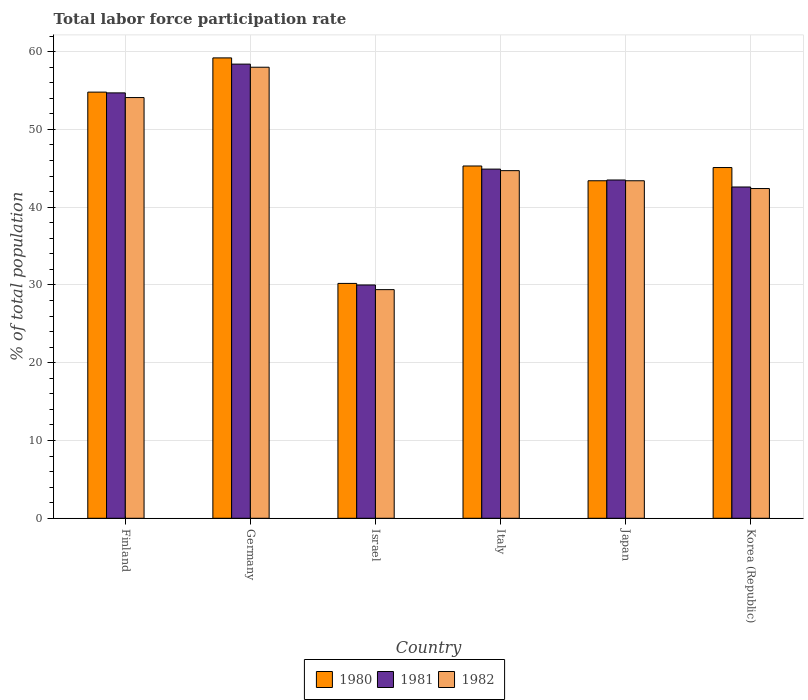How many different coloured bars are there?
Provide a short and direct response. 3. Are the number of bars per tick equal to the number of legend labels?
Give a very brief answer. Yes. Are the number of bars on each tick of the X-axis equal?
Ensure brevity in your answer.  Yes. How many bars are there on the 6th tick from the right?
Offer a very short reply. 3. In how many cases, is the number of bars for a given country not equal to the number of legend labels?
Provide a short and direct response. 0. What is the total labor force participation rate in 1982 in Israel?
Give a very brief answer. 29.4. Across all countries, what is the maximum total labor force participation rate in 1981?
Make the answer very short. 58.4. Across all countries, what is the minimum total labor force participation rate in 1982?
Provide a succinct answer. 29.4. What is the total total labor force participation rate in 1980 in the graph?
Your answer should be very brief. 278. What is the difference between the total labor force participation rate in 1981 in Germany and that in Italy?
Your answer should be compact. 13.5. What is the difference between the total labor force participation rate in 1981 in Germany and the total labor force participation rate in 1982 in Korea (Republic)?
Offer a very short reply. 16. What is the average total labor force participation rate in 1982 per country?
Make the answer very short. 45.33. What is the difference between the total labor force participation rate of/in 1982 and total labor force participation rate of/in 1981 in Italy?
Make the answer very short. -0.2. What is the ratio of the total labor force participation rate in 1980 in Finland to that in Italy?
Offer a terse response. 1.21. Is the difference between the total labor force participation rate in 1982 in Germany and Italy greater than the difference between the total labor force participation rate in 1981 in Germany and Italy?
Provide a succinct answer. No. What is the difference between the highest and the lowest total labor force participation rate in 1981?
Make the answer very short. 28.4. In how many countries, is the total labor force participation rate in 1981 greater than the average total labor force participation rate in 1981 taken over all countries?
Offer a very short reply. 2. What does the 3rd bar from the left in Finland represents?
Give a very brief answer. 1982. What does the 2nd bar from the right in Israel represents?
Your answer should be compact. 1981. Is it the case that in every country, the sum of the total labor force participation rate in 1980 and total labor force participation rate in 1982 is greater than the total labor force participation rate in 1981?
Offer a very short reply. Yes. How many countries are there in the graph?
Ensure brevity in your answer.  6. Are the values on the major ticks of Y-axis written in scientific E-notation?
Offer a terse response. No. Does the graph contain any zero values?
Your answer should be compact. No. Does the graph contain grids?
Offer a terse response. Yes. How many legend labels are there?
Offer a very short reply. 3. How are the legend labels stacked?
Your response must be concise. Horizontal. What is the title of the graph?
Keep it short and to the point. Total labor force participation rate. What is the label or title of the X-axis?
Keep it short and to the point. Country. What is the label or title of the Y-axis?
Ensure brevity in your answer.  % of total population. What is the % of total population of 1980 in Finland?
Keep it short and to the point. 54.8. What is the % of total population of 1981 in Finland?
Your answer should be compact. 54.7. What is the % of total population in 1982 in Finland?
Your answer should be very brief. 54.1. What is the % of total population of 1980 in Germany?
Provide a short and direct response. 59.2. What is the % of total population of 1981 in Germany?
Make the answer very short. 58.4. What is the % of total population in 1982 in Germany?
Your answer should be very brief. 58. What is the % of total population of 1980 in Israel?
Offer a very short reply. 30.2. What is the % of total population of 1981 in Israel?
Your answer should be compact. 30. What is the % of total population in 1982 in Israel?
Make the answer very short. 29.4. What is the % of total population in 1980 in Italy?
Your response must be concise. 45.3. What is the % of total population in 1981 in Italy?
Your answer should be very brief. 44.9. What is the % of total population of 1982 in Italy?
Offer a terse response. 44.7. What is the % of total population of 1980 in Japan?
Your answer should be very brief. 43.4. What is the % of total population in 1981 in Japan?
Give a very brief answer. 43.5. What is the % of total population in 1982 in Japan?
Keep it short and to the point. 43.4. What is the % of total population of 1980 in Korea (Republic)?
Provide a short and direct response. 45.1. What is the % of total population in 1981 in Korea (Republic)?
Make the answer very short. 42.6. What is the % of total population in 1982 in Korea (Republic)?
Your answer should be very brief. 42.4. Across all countries, what is the maximum % of total population in 1980?
Keep it short and to the point. 59.2. Across all countries, what is the maximum % of total population of 1981?
Keep it short and to the point. 58.4. Across all countries, what is the minimum % of total population of 1980?
Offer a very short reply. 30.2. Across all countries, what is the minimum % of total population of 1982?
Offer a very short reply. 29.4. What is the total % of total population of 1980 in the graph?
Your answer should be compact. 278. What is the total % of total population in 1981 in the graph?
Keep it short and to the point. 274.1. What is the total % of total population in 1982 in the graph?
Provide a succinct answer. 272. What is the difference between the % of total population of 1981 in Finland and that in Germany?
Give a very brief answer. -3.7. What is the difference between the % of total population of 1980 in Finland and that in Israel?
Give a very brief answer. 24.6. What is the difference between the % of total population in 1981 in Finland and that in Israel?
Offer a terse response. 24.7. What is the difference between the % of total population of 1982 in Finland and that in Israel?
Your answer should be very brief. 24.7. What is the difference between the % of total population in 1980 in Finland and that in Italy?
Offer a terse response. 9.5. What is the difference between the % of total population of 1981 in Finland and that in Japan?
Keep it short and to the point. 11.2. What is the difference between the % of total population of 1982 in Finland and that in Japan?
Make the answer very short. 10.7. What is the difference between the % of total population of 1981 in Germany and that in Israel?
Ensure brevity in your answer.  28.4. What is the difference between the % of total population in 1982 in Germany and that in Israel?
Your response must be concise. 28.6. What is the difference between the % of total population of 1981 in Germany and that in Japan?
Offer a terse response. 14.9. What is the difference between the % of total population in 1980 in Israel and that in Italy?
Your response must be concise. -15.1. What is the difference between the % of total population in 1981 in Israel and that in Italy?
Your response must be concise. -14.9. What is the difference between the % of total population in 1982 in Israel and that in Italy?
Ensure brevity in your answer.  -15.3. What is the difference between the % of total population of 1980 in Israel and that in Korea (Republic)?
Give a very brief answer. -14.9. What is the difference between the % of total population of 1982 in Israel and that in Korea (Republic)?
Offer a very short reply. -13. What is the difference between the % of total population of 1980 in Italy and that in Japan?
Provide a short and direct response. 1.9. What is the difference between the % of total population in 1981 in Italy and that in Japan?
Provide a short and direct response. 1.4. What is the difference between the % of total population in 1981 in Italy and that in Korea (Republic)?
Provide a short and direct response. 2.3. What is the difference between the % of total population of 1982 in Italy and that in Korea (Republic)?
Offer a very short reply. 2.3. What is the difference between the % of total population in 1980 in Japan and that in Korea (Republic)?
Give a very brief answer. -1.7. What is the difference between the % of total population of 1981 in Japan and that in Korea (Republic)?
Offer a terse response. 0.9. What is the difference between the % of total population in 1980 in Finland and the % of total population in 1981 in Germany?
Offer a very short reply. -3.6. What is the difference between the % of total population of 1980 in Finland and the % of total population of 1981 in Israel?
Offer a very short reply. 24.8. What is the difference between the % of total population of 1980 in Finland and the % of total population of 1982 in Israel?
Offer a very short reply. 25.4. What is the difference between the % of total population of 1981 in Finland and the % of total population of 1982 in Israel?
Offer a very short reply. 25.3. What is the difference between the % of total population in 1980 in Finland and the % of total population in 1981 in Italy?
Provide a short and direct response. 9.9. What is the difference between the % of total population of 1981 in Finland and the % of total population of 1982 in Italy?
Your answer should be very brief. 10. What is the difference between the % of total population in 1980 in Finland and the % of total population in 1982 in Japan?
Provide a short and direct response. 11.4. What is the difference between the % of total population in 1981 in Finland and the % of total population in 1982 in Japan?
Your answer should be very brief. 11.3. What is the difference between the % of total population in 1980 in Finland and the % of total population in 1981 in Korea (Republic)?
Your answer should be compact. 12.2. What is the difference between the % of total population of 1980 in Finland and the % of total population of 1982 in Korea (Republic)?
Provide a succinct answer. 12.4. What is the difference between the % of total population of 1980 in Germany and the % of total population of 1981 in Israel?
Provide a short and direct response. 29.2. What is the difference between the % of total population in 1980 in Germany and the % of total population in 1982 in Israel?
Your answer should be very brief. 29.8. What is the difference between the % of total population of 1981 in Germany and the % of total population of 1982 in Italy?
Your answer should be very brief. 13.7. What is the difference between the % of total population of 1980 in Germany and the % of total population of 1982 in Japan?
Ensure brevity in your answer.  15.8. What is the difference between the % of total population of 1981 in Germany and the % of total population of 1982 in Japan?
Ensure brevity in your answer.  15. What is the difference between the % of total population in 1980 in Germany and the % of total population in 1982 in Korea (Republic)?
Offer a very short reply. 16.8. What is the difference between the % of total population of 1981 in Germany and the % of total population of 1982 in Korea (Republic)?
Make the answer very short. 16. What is the difference between the % of total population of 1980 in Israel and the % of total population of 1981 in Italy?
Give a very brief answer. -14.7. What is the difference between the % of total population of 1980 in Israel and the % of total population of 1982 in Italy?
Offer a terse response. -14.5. What is the difference between the % of total population of 1981 in Israel and the % of total population of 1982 in Italy?
Your response must be concise. -14.7. What is the difference between the % of total population of 1980 in Israel and the % of total population of 1982 in Japan?
Your response must be concise. -13.2. What is the difference between the % of total population of 1981 in Israel and the % of total population of 1982 in Korea (Republic)?
Provide a succinct answer. -12.4. What is the difference between the % of total population of 1980 in Italy and the % of total population of 1981 in Japan?
Your answer should be compact. 1.8. What is the difference between the % of total population of 1980 in Italy and the % of total population of 1982 in Japan?
Give a very brief answer. 1.9. What is the difference between the % of total population of 1981 in Italy and the % of total population of 1982 in Japan?
Keep it short and to the point. 1.5. What is the difference between the % of total population of 1981 in Italy and the % of total population of 1982 in Korea (Republic)?
Your answer should be very brief. 2.5. What is the difference between the % of total population in 1980 in Japan and the % of total population in 1982 in Korea (Republic)?
Keep it short and to the point. 1. What is the average % of total population of 1980 per country?
Offer a very short reply. 46.33. What is the average % of total population of 1981 per country?
Give a very brief answer. 45.68. What is the average % of total population of 1982 per country?
Offer a terse response. 45.33. What is the difference between the % of total population of 1980 and % of total population of 1981 in Finland?
Provide a short and direct response. 0.1. What is the difference between the % of total population in 1980 and % of total population in 1981 in Germany?
Keep it short and to the point. 0.8. What is the difference between the % of total population in 1980 and % of total population in 1982 in Germany?
Provide a succinct answer. 1.2. What is the difference between the % of total population in 1981 and % of total population in 1982 in Germany?
Keep it short and to the point. 0.4. What is the difference between the % of total population in 1981 and % of total population in 1982 in Israel?
Provide a succinct answer. 0.6. What is the difference between the % of total population in 1981 and % of total population in 1982 in Italy?
Offer a terse response. 0.2. What is the difference between the % of total population of 1980 and % of total population of 1981 in Japan?
Offer a terse response. -0.1. What is the difference between the % of total population of 1980 and % of total population of 1982 in Japan?
Provide a succinct answer. 0. What is the difference between the % of total population of 1981 and % of total population of 1982 in Japan?
Offer a terse response. 0.1. What is the difference between the % of total population of 1980 and % of total population of 1981 in Korea (Republic)?
Offer a very short reply. 2.5. What is the difference between the % of total population of 1981 and % of total population of 1982 in Korea (Republic)?
Provide a succinct answer. 0.2. What is the ratio of the % of total population of 1980 in Finland to that in Germany?
Ensure brevity in your answer.  0.93. What is the ratio of the % of total population in 1981 in Finland to that in Germany?
Your response must be concise. 0.94. What is the ratio of the % of total population of 1982 in Finland to that in Germany?
Ensure brevity in your answer.  0.93. What is the ratio of the % of total population in 1980 in Finland to that in Israel?
Your answer should be very brief. 1.81. What is the ratio of the % of total population in 1981 in Finland to that in Israel?
Ensure brevity in your answer.  1.82. What is the ratio of the % of total population of 1982 in Finland to that in Israel?
Your answer should be very brief. 1.84. What is the ratio of the % of total population in 1980 in Finland to that in Italy?
Give a very brief answer. 1.21. What is the ratio of the % of total population of 1981 in Finland to that in Italy?
Ensure brevity in your answer.  1.22. What is the ratio of the % of total population of 1982 in Finland to that in Italy?
Your answer should be compact. 1.21. What is the ratio of the % of total population of 1980 in Finland to that in Japan?
Make the answer very short. 1.26. What is the ratio of the % of total population in 1981 in Finland to that in Japan?
Your response must be concise. 1.26. What is the ratio of the % of total population in 1982 in Finland to that in Japan?
Offer a very short reply. 1.25. What is the ratio of the % of total population in 1980 in Finland to that in Korea (Republic)?
Offer a terse response. 1.22. What is the ratio of the % of total population of 1981 in Finland to that in Korea (Republic)?
Give a very brief answer. 1.28. What is the ratio of the % of total population in 1982 in Finland to that in Korea (Republic)?
Offer a terse response. 1.28. What is the ratio of the % of total population in 1980 in Germany to that in Israel?
Offer a very short reply. 1.96. What is the ratio of the % of total population in 1981 in Germany to that in Israel?
Give a very brief answer. 1.95. What is the ratio of the % of total population of 1982 in Germany to that in Israel?
Ensure brevity in your answer.  1.97. What is the ratio of the % of total population in 1980 in Germany to that in Italy?
Make the answer very short. 1.31. What is the ratio of the % of total population in 1981 in Germany to that in Italy?
Offer a very short reply. 1.3. What is the ratio of the % of total population of 1982 in Germany to that in Italy?
Your answer should be very brief. 1.3. What is the ratio of the % of total population in 1980 in Germany to that in Japan?
Your response must be concise. 1.36. What is the ratio of the % of total population in 1981 in Germany to that in Japan?
Keep it short and to the point. 1.34. What is the ratio of the % of total population of 1982 in Germany to that in Japan?
Offer a very short reply. 1.34. What is the ratio of the % of total population of 1980 in Germany to that in Korea (Republic)?
Your answer should be very brief. 1.31. What is the ratio of the % of total population of 1981 in Germany to that in Korea (Republic)?
Provide a succinct answer. 1.37. What is the ratio of the % of total population in 1982 in Germany to that in Korea (Republic)?
Offer a very short reply. 1.37. What is the ratio of the % of total population of 1980 in Israel to that in Italy?
Offer a terse response. 0.67. What is the ratio of the % of total population in 1981 in Israel to that in Italy?
Provide a succinct answer. 0.67. What is the ratio of the % of total population of 1982 in Israel to that in Italy?
Make the answer very short. 0.66. What is the ratio of the % of total population in 1980 in Israel to that in Japan?
Your answer should be compact. 0.7. What is the ratio of the % of total population in 1981 in Israel to that in Japan?
Your answer should be compact. 0.69. What is the ratio of the % of total population in 1982 in Israel to that in Japan?
Your response must be concise. 0.68. What is the ratio of the % of total population in 1980 in Israel to that in Korea (Republic)?
Your answer should be very brief. 0.67. What is the ratio of the % of total population in 1981 in Israel to that in Korea (Republic)?
Provide a succinct answer. 0.7. What is the ratio of the % of total population of 1982 in Israel to that in Korea (Republic)?
Offer a terse response. 0.69. What is the ratio of the % of total population of 1980 in Italy to that in Japan?
Offer a terse response. 1.04. What is the ratio of the % of total population in 1981 in Italy to that in Japan?
Provide a short and direct response. 1.03. What is the ratio of the % of total population of 1982 in Italy to that in Japan?
Give a very brief answer. 1.03. What is the ratio of the % of total population in 1980 in Italy to that in Korea (Republic)?
Offer a terse response. 1. What is the ratio of the % of total population in 1981 in Italy to that in Korea (Republic)?
Your answer should be very brief. 1.05. What is the ratio of the % of total population in 1982 in Italy to that in Korea (Republic)?
Provide a short and direct response. 1.05. What is the ratio of the % of total population of 1980 in Japan to that in Korea (Republic)?
Your answer should be compact. 0.96. What is the ratio of the % of total population of 1981 in Japan to that in Korea (Republic)?
Keep it short and to the point. 1.02. What is the ratio of the % of total population of 1982 in Japan to that in Korea (Republic)?
Keep it short and to the point. 1.02. What is the difference between the highest and the second highest % of total population in 1981?
Provide a succinct answer. 3.7. What is the difference between the highest and the lowest % of total population of 1981?
Offer a very short reply. 28.4. What is the difference between the highest and the lowest % of total population in 1982?
Keep it short and to the point. 28.6. 